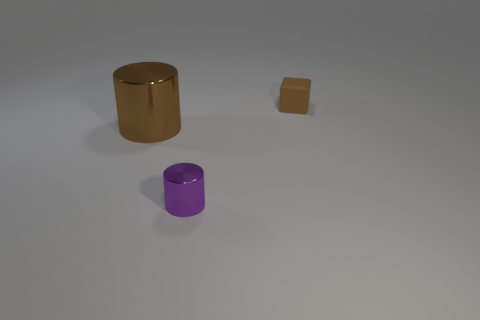Is there any other thing that has the same material as the small brown object?
Your answer should be very brief. No. There is a brown object that is on the left side of the tiny purple shiny object; what is it made of?
Your response must be concise. Metal. There is a brown object that is on the left side of the brown matte thing; is its shape the same as the purple metal thing?
Your answer should be compact. Yes. Is there a brown matte cube that has the same size as the purple thing?
Ensure brevity in your answer.  Yes. Does the purple object have the same shape as the brown object to the left of the brown matte thing?
Offer a terse response. Yes. What shape is the big shiny thing that is the same color as the small block?
Provide a short and direct response. Cylinder. Are there fewer small shiny things that are to the right of the small rubber block than big brown objects?
Ensure brevity in your answer.  Yes. Is the shape of the purple thing the same as the large brown thing?
Make the answer very short. Yes. What size is the cylinder that is the same material as the small purple thing?
Keep it short and to the point. Large. Are there fewer small blue matte spheres than big shiny cylinders?
Your answer should be compact. Yes. 